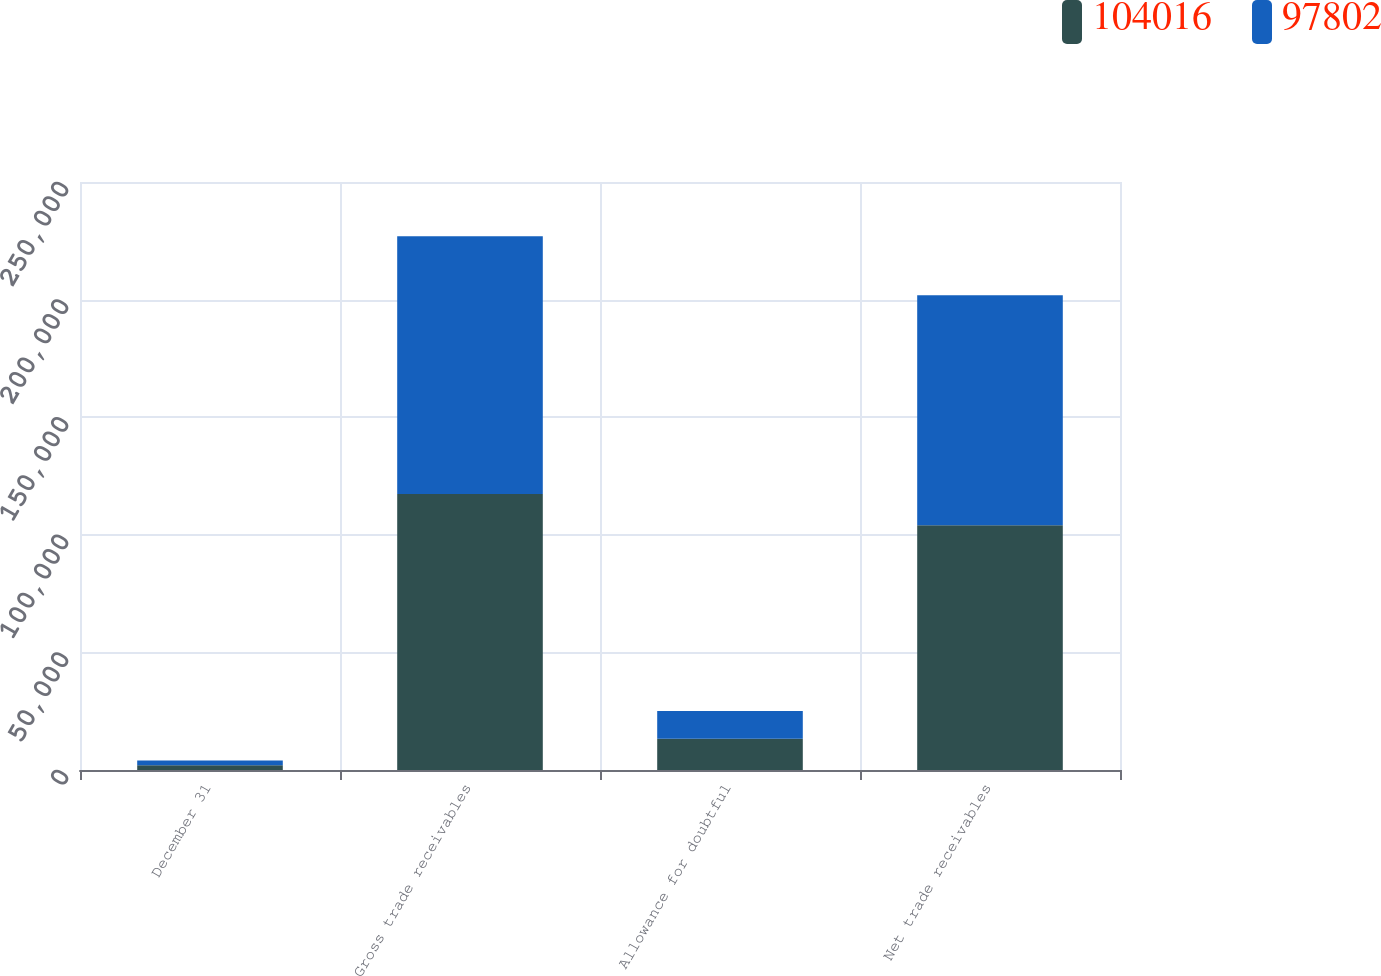Convert chart. <chart><loc_0><loc_0><loc_500><loc_500><stacked_bar_chart><ecel><fcel>December 31<fcel>Gross trade receivables<fcel>Allowance for doubtful<fcel>Net trade receivables<nl><fcel>104016<fcel>2018<fcel>117301<fcel>13285<fcel>104016<nl><fcel>97802<fcel>2017<fcel>109616<fcel>11814<fcel>97802<nl></chart> 